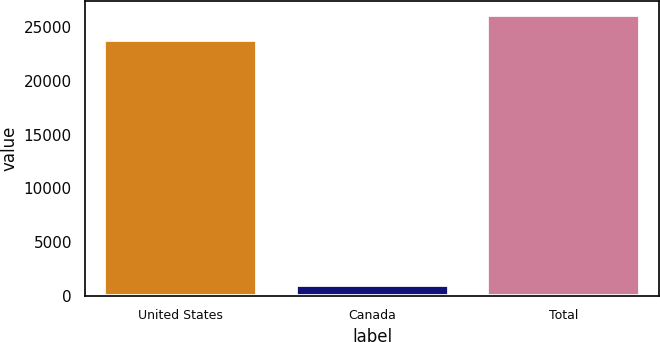Convert chart. <chart><loc_0><loc_0><loc_500><loc_500><bar_chart><fcel>United States<fcel>Canada<fcel>Total<nl><fcel>23770<fcel>1031<fcel>26147<nl></chart> 